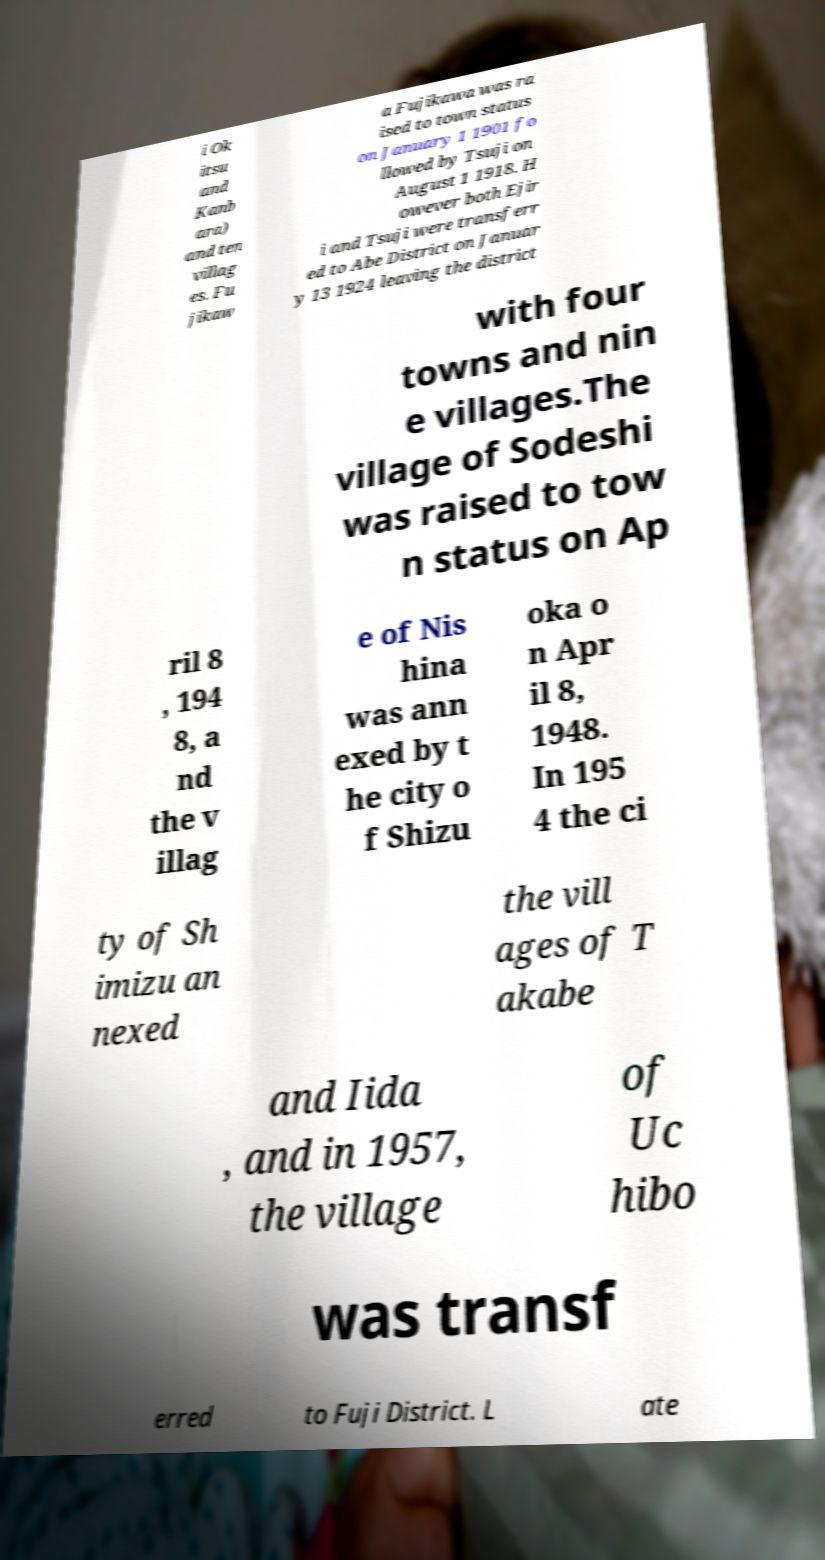What messages or text are displayed in this image? I need them in a readable, typed format. i Ok itsu and Kanb ara) and ten villag es. Fu jikaw a Fujikawa was ra ised to town status on January 1 1901 fo llowed by Tsuji on August 1 1918. H owever both Ejir i and Tsuji were transferr ed to Abe District on Januar y 13 1924 leaving the district with four towns and nin e villages.The village of Sodeshi was raised to tow n status on Ap ril 8 , 194 8, a nd the v illag e of Nis hina was ann exed by t he city o f Shizu oka o n Apr il 8, 1948. In 195 4 the ci ty of Sh imizu an nexed the vill ages of T akabe and Iida , and in 1957, the village of Uc hibo was transf erred to Fuji District. L ate 